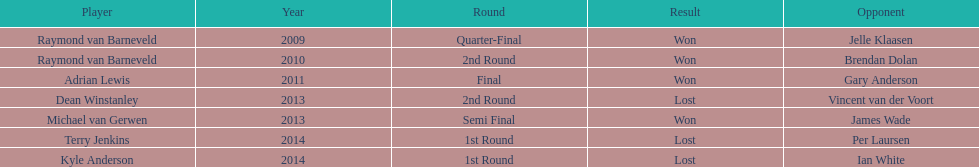Who were all the competitors? Raymond van Barneveld, Raymond van Barneveld, Adrian Lewis, Dean Winstanley, Michael van Gerwen, Terry Jenkins, Kyle Anderson. Which of them took part in 2014? Terry Jenkins, Kyle Anderson. Who were their challengers? Per Laursen, Ian White. Which of these bested terry jenkins? Per Laursen. 